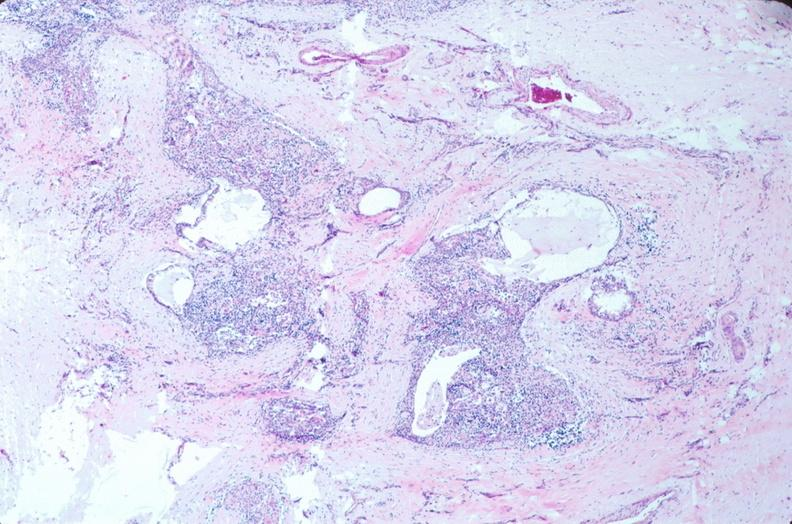what does this image show?
Answer the question using a single word or phrase. Pharyngeal pouch remnant 